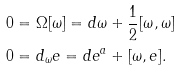Convert formula to latex. <formula><loc_0><loc_0><loc_500><loc_500>& 0 = \Omega [ \omega ] = d \omega + \frac { 1 } { 2 } [ \omega , \omega ] \\ & 0 = d _ { \omega } e = d e ^ { a } + [ \omega , e ] .</formula> 